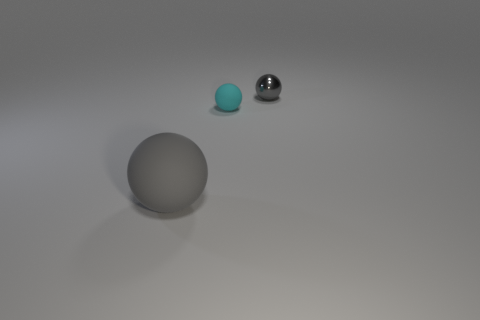Are there any other things that are the same material as the small gray sphere?
Provide a short and direct response. No. How many small objects are either cyan rubber things or balls?
Give a very brief answer. 2. There is a gray object that is in front of the metal object; are there any tiny gray objects that are on the left side of it?
Give a very brief answer. No. Are any tiny gray metal spheres visible?
Make the answer very short. Yes. What is the color of the matte ball behind the gray thing in front of the small metallic thing?
Your answer should be very brief. Cyan. There is a large gray thing that is the same shape as the small rubber thing; what is it made of?
Make the answer very short. Rubber. What number of gray shiny spheres have the same size as the cyan matte object?
Provide a succinct answer. 1. There is a cyan sphere that is made of the same material as the large gray thing; what size is it?
Ensure brevity in your answer.  Small. What number of other small things have the same shape as the tiny cyan matte thing?
Provide a succinct answer. 1. How many rubber objects are there?
Offer a very short reply. 2. 